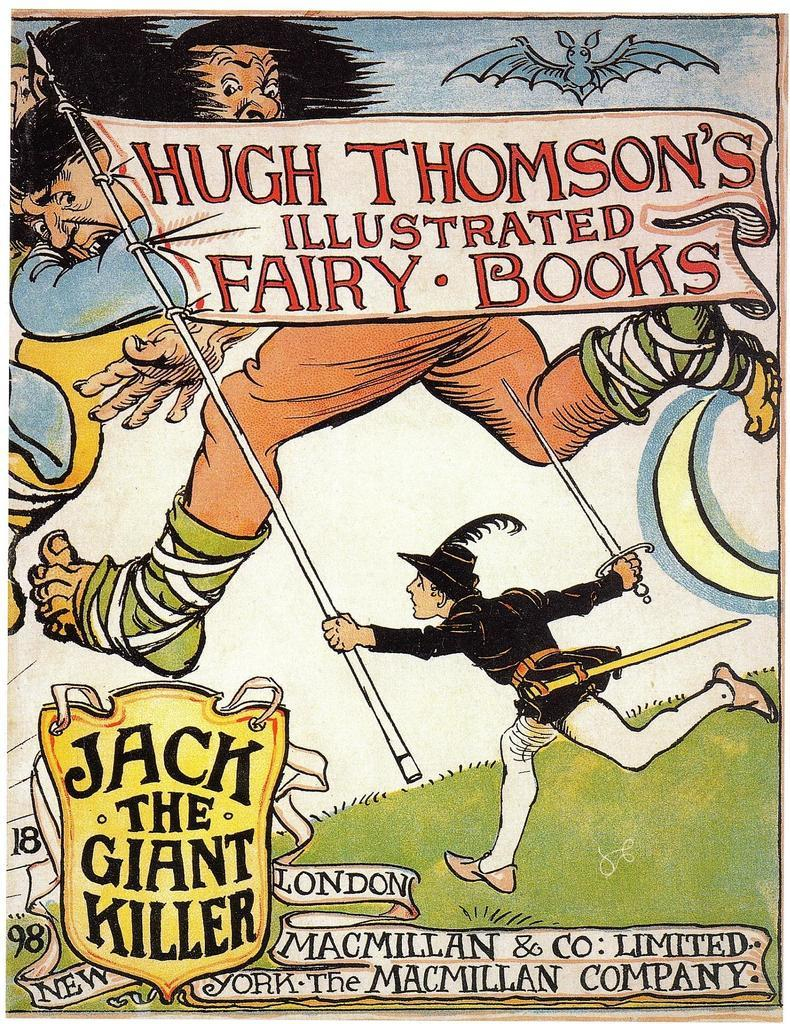<image>
Present a compact description of the photo's key features. The children's book shown here is Jack The Giant Killer. 